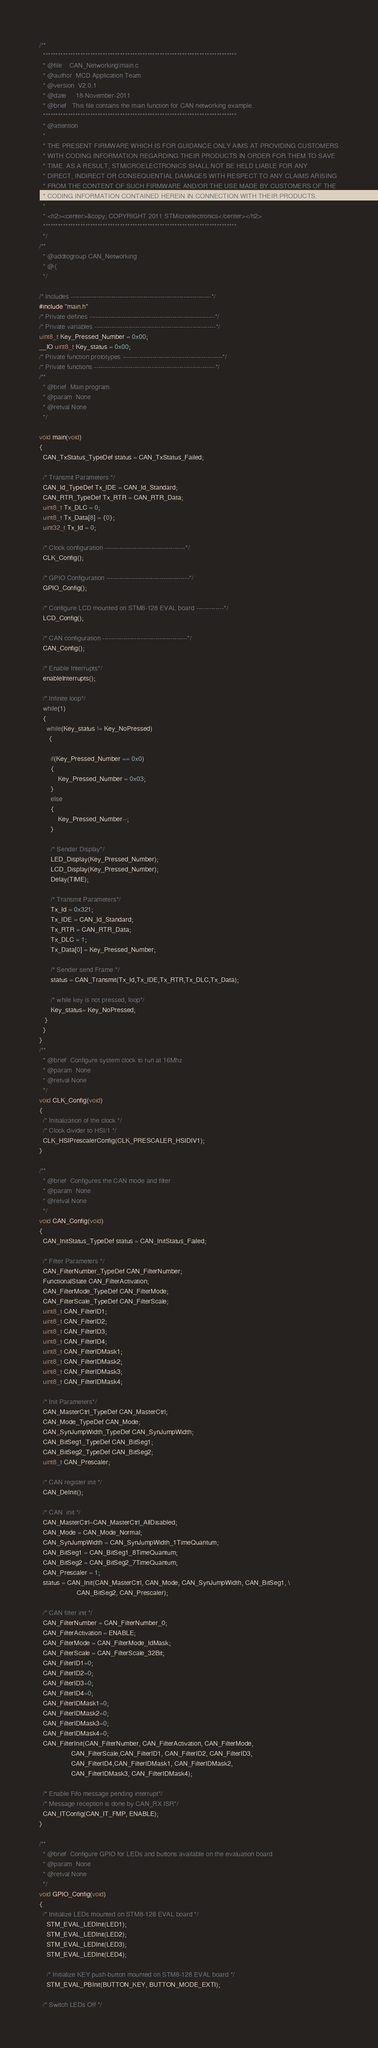<code> <loc_0><loc_0><loc_500><loc_500><_C_>/**
  ******************************************************************************
  * @file    CAN_Networking\main.c
  * @author  MCD Application Team
  * @version  V2.0.1
  * @date     18-November-2011
  * @brief   This file contains the main function for CAN networking example.
  ******************************************************************************
  * @attention
  *
  * THE PRESENT FIRMWARE WHICH IS FOR GUIDANCE ONLY AIMS AT PROVIDING CUSTOMERS
  * WITH CODING INFORMATION REGARDING THEIR PRODUCTS IN ORDER FOR THEM TO SAVE
  * TIME. AS A RESULT, STMICROELECTRONICS SHALL NOT BE HELD LIABLE FOR ANY
  * DIRECT, INDIRECT OR CONSEQUENTIAL DAMAGES WITH RESPECT TO ANY CLAIMS ARISING
  * FROM THE CONTENT OF SUCH FIRMWARE AND/OR THE USE MADE BY CUSTOMERS OF THE
  * CODING INFORMATION CONTAINED HEREIN IN CONNECTION WITH THEIR PRODUCTS.
  *
  * <h2><center>&copy; COPYRIGHT 2011 STMicroelectronics</center></h2>
  ******************************************************************************
  */ 
/**
  * @addtogroup CAN_Networking
  * @{
  */

/* Includes ------------------------------------------------------------------*/
#include "main.h"
/* Private defines -----------------------------------------------------------*/
/* Private variables ---------------------------------------------------------*/
uint8_t Key_Pressed_Number = 0x00;
__IO uint8_t Key_status = 0x00;
/* Private function prototypes -----------------------------------------------*/
/* Private functions ---------------------------------------------------------*/
/**
  * @brief  Main program.
  * @param  None
  * @retval None
  */  

void main(void)
{
  CAN_TxStatus_TypeDef status = CAN_TxStatus_Failed;
  
  /* Transmit Parameters */
  CAN_Id_TypeDef Tx_IDE = CAN_Id_Standard;
  CAN_RTR_TypeDef Tx_RTR = CAN_RTR_Data;
  uint8_t Tx_DLC = 0;
  uint8_t Tx_Data[8] = {0};
  uint32_t Tx_Id = 0;
  
  /* Clock configuration --------------------------------------*/
  CLK_Config();
  
  /* GPIO Configuration ---------------------------------------*/
  GPIO_Config();
    
  /* Configure LCD mounted on STM8-128 EVAL board -------------*/
  LCD_Config();
  
  /* CAN configuration ----------------------------------------*/
  CAN_Config();
  
  /* Enable Interrupts*/
  enableInterrupts();

  /* Infinite loop*/
  while(1)
  {
    while(Key_status != Key_NoPressed)
     {
    
      if(Key_Pressed_Number == 0x0) 
      {
          Key_Pressed_Number = 0x03;
      }
      else
      {
          Key_Pressed_Number--;
      }
      
      /* Sender Display*/
      LED_Display(Key_Pressed_Number);
      LCD_Display(Key_Pressed_Number);
      Delay(TIME);
      
      /* Transmit Parameters*/
      Tx_Id = 0x321;
      Tx_IDE = CAN_Id_Standard;
      Tx_RTR = CAN_RTR_Data;
      Tx_DLC = 1;
      Tx_Data[0] = Key_Pressed_Number;
      
      /* Sender send Frame */
      status = CAN_Transmit(Tx_Id,Tx_IDE,Tx_RTR,Tx_DLC,Tx_Data);
      
      /* while key is not pressed, loop*/
      Key_status= Key_NoPressed;
   }
  }
}
/**
  * @brief  Configure system clock to run at 16Mhz
  * @param  None
  * @retval None
  */
void CLK_Config(void)
{
  /* Initialization of the clock */
  /* Clock divider to HSI/1 */
  CLK_HSIPrescalerConfig(CLK_PRESCALER_HSIDIV1);
}

/**
  * @brief  Configures the CAN mode and filter
  * @param  None
  * @retval None
  */
void CAN_Config(void)
{
  CAN_InitStatus_TypeDef status = CAN_InitStatus_Failed;
  
  /* Filter Parameters */
  CAN_FilterNumber_TypeDef CAN_FilterNumber;
  FunctionalState CAN_FilterActivation;
  CAN_FilterMode_TypeDef CAN_FilterMode;
  CAN_FilterScale_TypeDef CAN_FilterScale;
  uint8_t CAN_FilterID1;
  uint8_t CAN_FilterID2;
  uint8_t CAN_FilterID3;
  uint8_t CAN_FilterID4;
  uint8_t CAN_FilterIDMask1;
  uint8_t CAN_FilterIDMask2;
  uint8_t CAN_FilterIDMask3;
  uint8_t CAN_FilterIDMask4; 
  
  /* Init Parameters*/
  CAN_MasterCtrl_TypeDef CAN_MasterCtrl;
  CAN_Mode_TypeDef CAN_Mode;
  CAN_SynJumpWidth_TypeDef CAN_SynJumpWidth;
  CAN_BitSeg1_TypeDef CAN_BitSeg1;
  CAN_BitSeg2_TypeDef CAN_BitSeg2;
  uint8_t CAN_Prescaler;  
  
  /* CAN register init */
  CAN_DeInit();
    
  /* CAN  init */
  CAN_MasterCtrl=CAN_MasterCtrl_AllDisabled;
  CAN_Mode = CAN_Mode_Normal;
  CAN_SynJumpWidth = CAN_SynJumpWidth_1TimeQuantum;
  CAN_BitSeg1 = CAN_BitSeg1_8TimeQuantum;
  CAN_BitSeg2 = CAN_BitSeg2_7TimeQuantum;
  CAN_Prescaler = 1;
  status = CAN_Init(CAN_MasterCtrl, CAN_Mode, CAN_SynJumpWidth, CAN_BitSeg1, \
                    CAN_BitSeg2, CAN_Prescaler);

  /* CAN filter init */
  CAN_FilterNumber = CAN_FilterNumber_0;
  CAN_FilterActivation = ENABLE;
  CAN_FilterMode = CAN_FilterMode_IdMask;
  CAN_FilterScale = CAN_FilterScale_32Bit;
  CAN_FilterID1=0;  
  CAN_FilterID2=0;
  CAN_FilterID3=0;
  CAN_FilterID4=0;
  CAN_FilterIDMask1=0;
  CAN_FilterIDMask2=0;
  CAN_FilterIDMask3=0;
  CAN_FilterIDMask4=0;  
  CAN_FilterInit(CAN_FilterNumber, CAN_FilterActivation, CAN_FilterMode, 
                 CAN_FilterScale,CAN_FilterID1, CAN_FilterID2, CAN_FilterID3,
                 CAN_FilterID4,CAN_FilterIDMask1, CAN_FilterIDMask2, 
                 CAN_FilterIDMask3, CAN_FilterIDMask4);
        
  /* Enable Fifo message pending interrupt*/
  /* Message reception is done by CAN_RX ISR*/
  CAN_ITConfig(CAN_IT_FMP, ENABLE);
}

/**
  * @brief  Configure GPIO for LEDs and buttons available on the evaluation board
  * @param  None
  * @retval None
  */
void GPIO_Config(void)
{
  /* Initialize LEDs mounted on STM8-128 EVAL board */
    STM_EVAL_LEDInit(LED1);
    STM_EVAL_LEDInit(LED2);
    STM_EVAL_LEDInit(LED3);
    STM_EVAL_LEDInit(LED4);
    
    /* Initialize KEY push-button mounted on STM8-128 EVAL board */
    STM_EVAL_PBInit(BUTTON_KEY, BUTTON_MODE_EXTI);
  
  /* Switch LEDs Off */</code> 